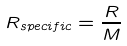Convert formula to latex. <formula><loc_0><loc_0><loc_500><loc_500>R _ { s p e c i f i c } = \frac { R } { M }</formula> 